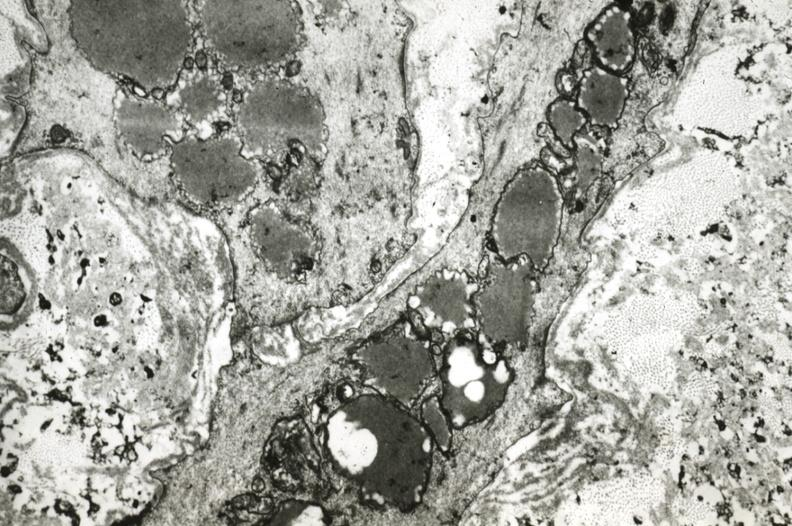what is present?
Answer the question using a single word or phrase. Vasculature 